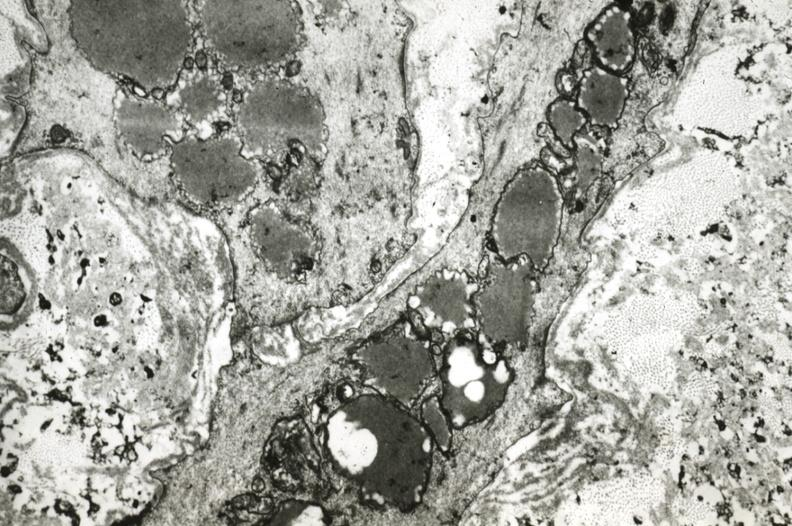what is present?
Answer the question using a single word or phrase. Vasculature 